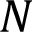Convert formula to latex. <formula><loc_0><loc_0><loc_500><loc_500>N</formula> 